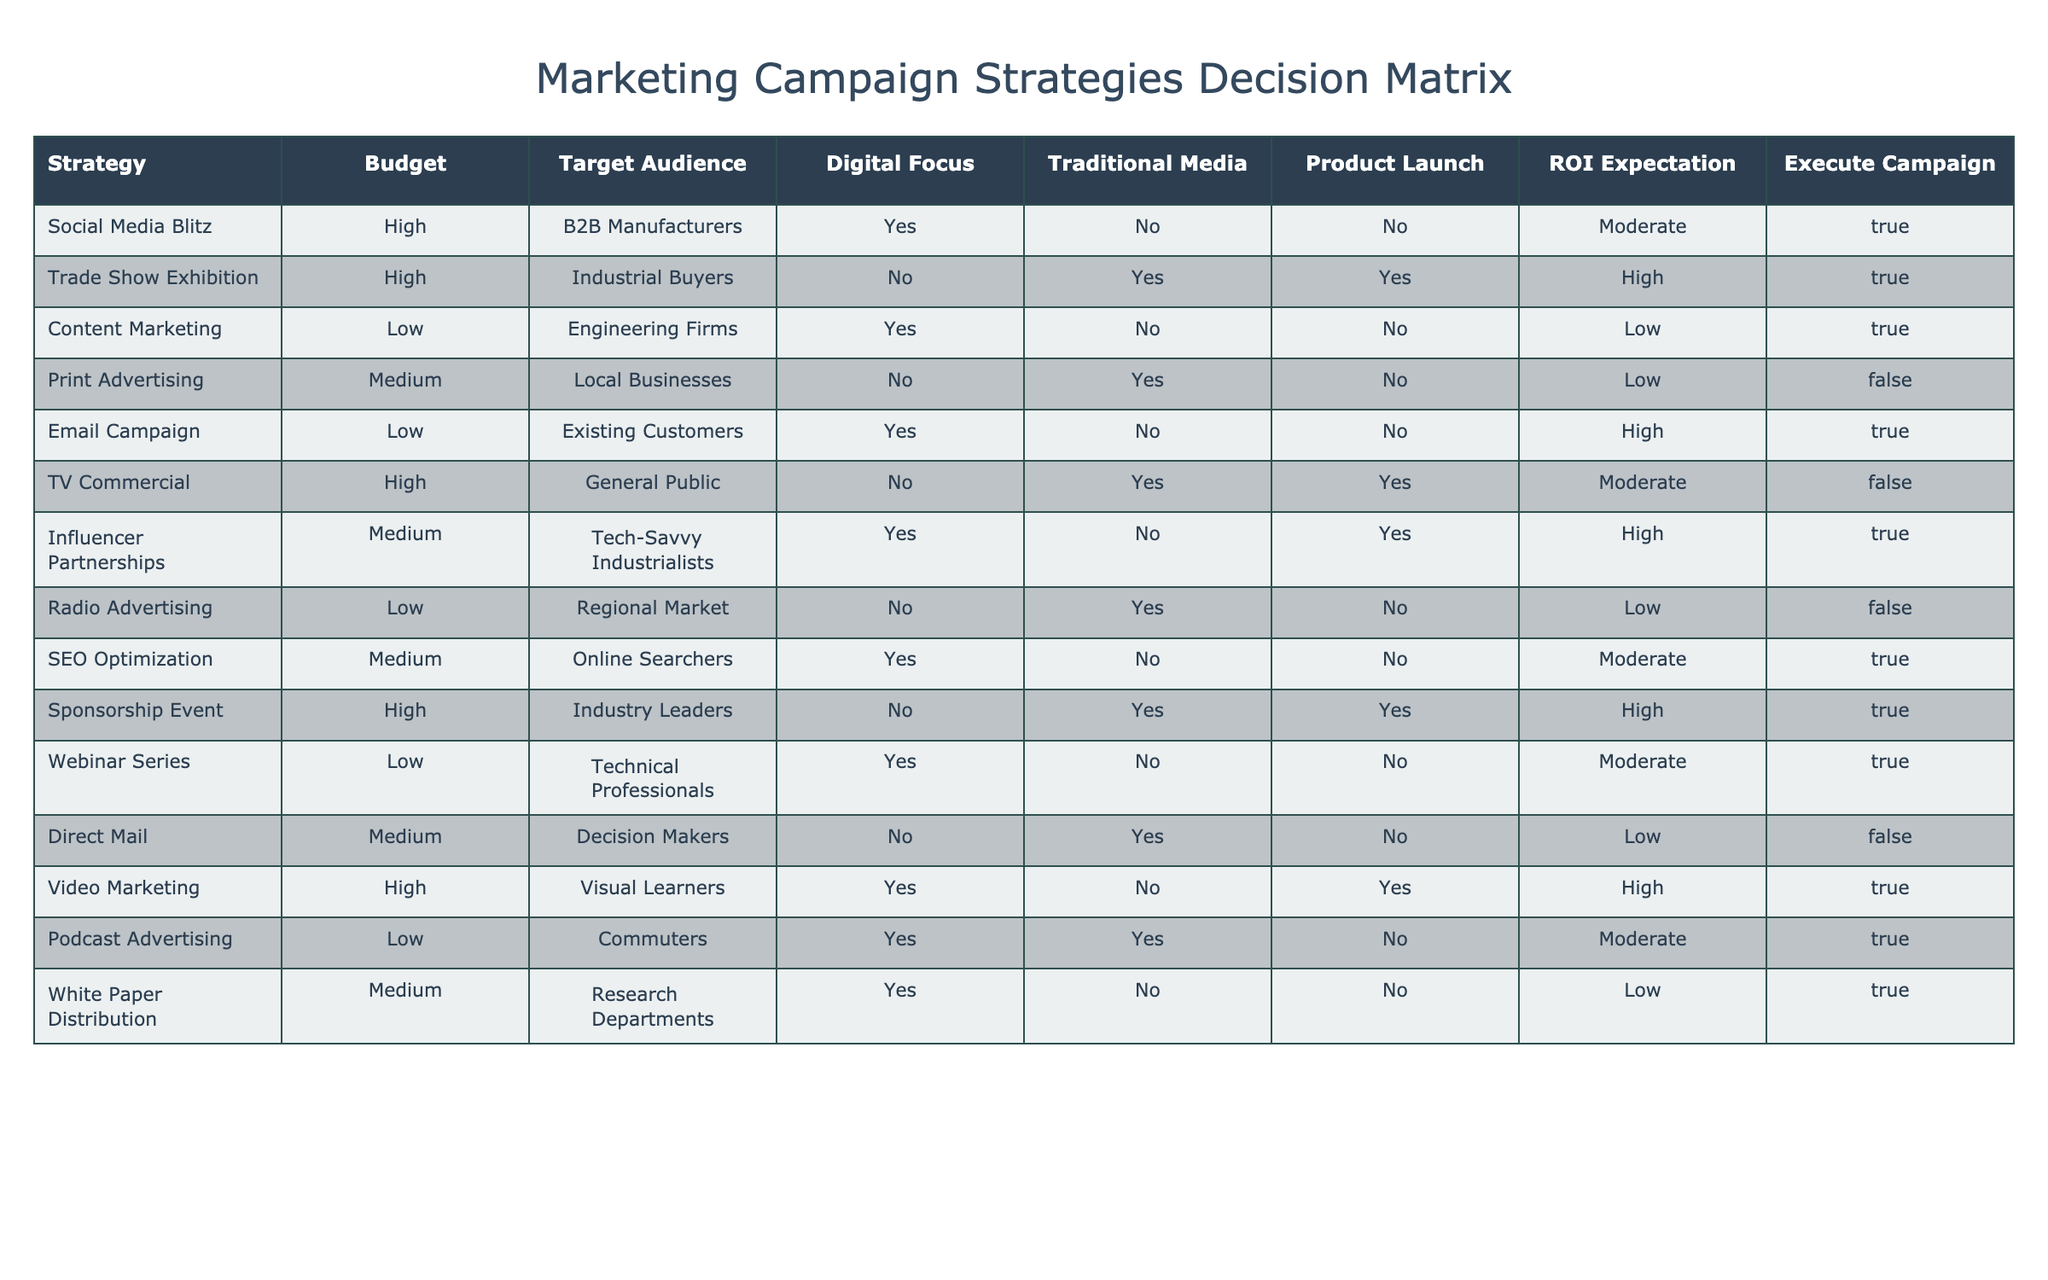What marketing strategy targets B2B Manufacturers? By looking at the "Target Audience" column, the "Social Media Blitz" strategy is listed as targeting B2B Manufacturers.
Answer: Social Media Blitz How many strategies have a Low ROI Expectation? To find this, we count the number of rows where "ROI Expectation" is labeled as Low. There are 4 strategies that meet this criterion: Content Marketing, Print Advertising, Radio Advertising, and White Paper Distribution.
Answer: 4 Is there a strategy that has both Digital Focus and a High ROI Expectation? Checking the "Digital Focus" and "ROI Expectation" columns, the "Influencer Partnerships" and "Email Campaign" strategies have a Digital Focus, and only "Influencer Partnerships" has a High ROI Expectation.
Answer: Yes, Influencer Partnerships What is the average budget level of strategies that use Traditional Media? First, identify the budget levels for strategies where "Traditional Media" is Yes, which are Trade Show Exhibition, Print Advertising, TV Commercial, Radio Advertising, and Sponsorship Event. Their corresponding budget levels are High for Trade Show Exhibition and Sponsorship Event, Medium for Print Advertising, and Radio Advertising, and High for TV Commercial. Assign numerical values to budgets: High = 3, Medium = 2, Low = 1. Total values (3 + 2 + 3 + 1 + 3 = 12) and divide by the number of strategies (5), resulting in an average of 12 / 5 = 2.4, which corresponds to a Medium budget.
Answer: Medium Which strategy is the only one with a Traditional Media focus but no expected ROI? Looking through the table, the only strategy with a Yes in "Traditional Media," No in "Digital Focus," and does not have an affirmative "ROI Expectation" is Direct Mail.
Answer: Direct Mail 